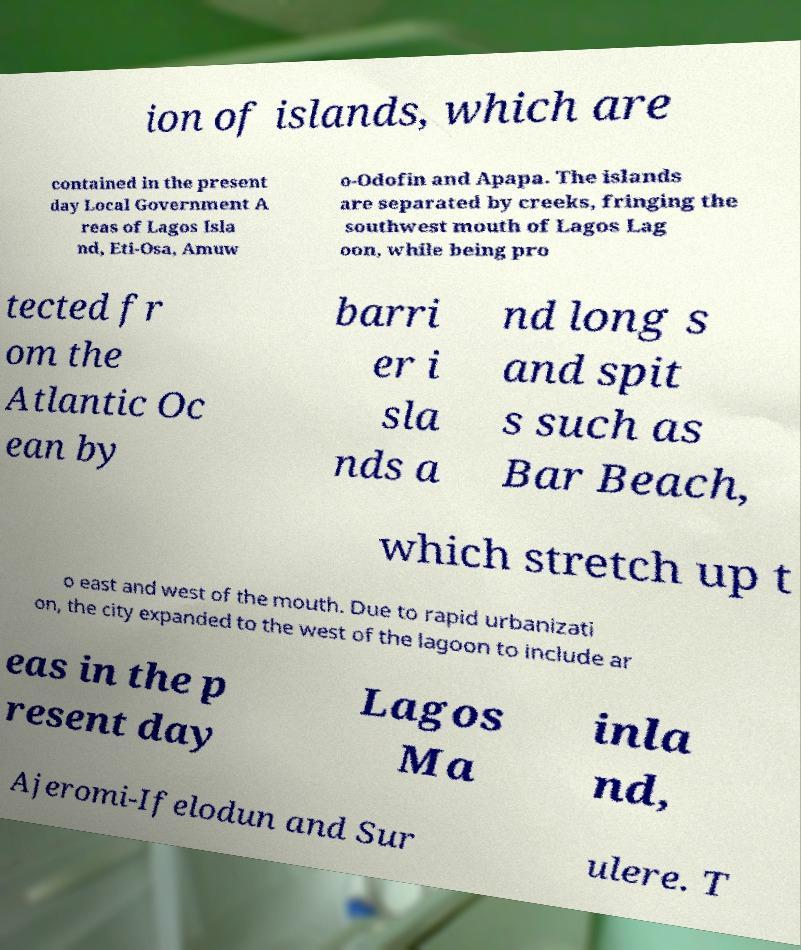Could you assist in decoding the text presented in this image and type it out clearly? ion of islands, which are contained in the present day Local Government A reas of Lagos Isla nd, Eti-Osa, Amuw o-Odofin and Apapa. The islands are separated by creeks, fringing the southwest mouth of Lagos Lag oon, while being pro tected fr om the Atlantic Oc ean by barri er i sla nds a nd long s and spit s such as Bar Beach, which stretch up t o east and west of the mouth. Due to rapid urbanizati on, the city expanded to the west of the lagoon to include ar eas in the p resent day Lagos Ma inla nd, Ajeromi-Ifelodun and Sur ulere. T 